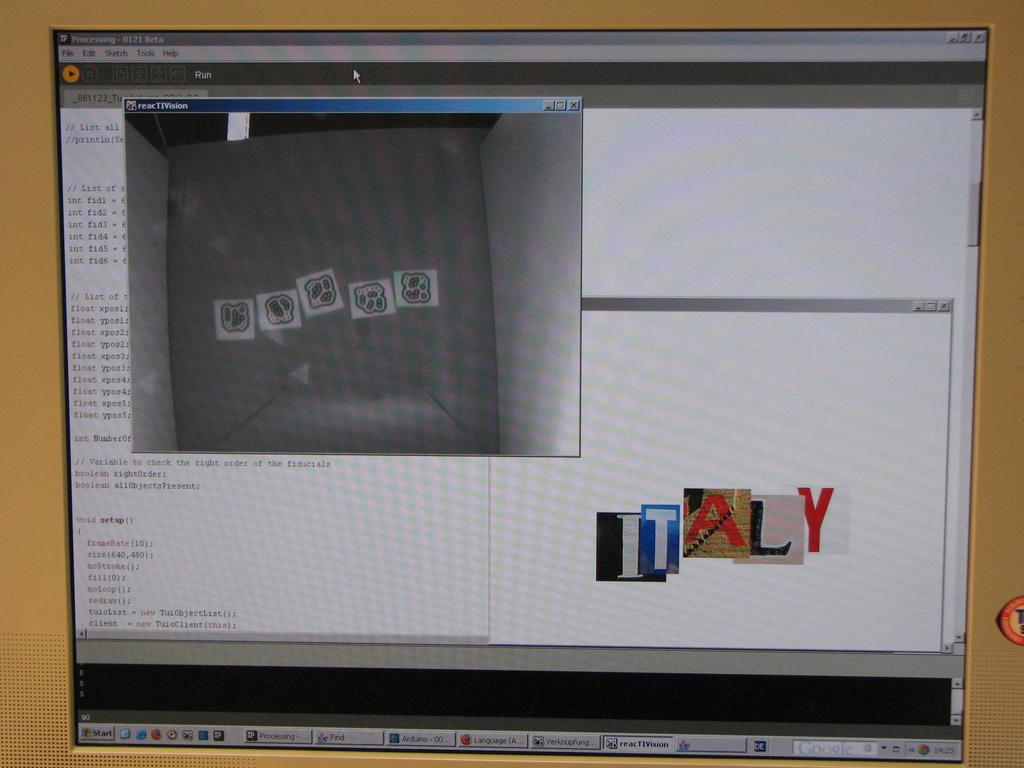<image>
Offer a succinct explanation of the picture presented. Computer monitor showing the word ITALY on it. 